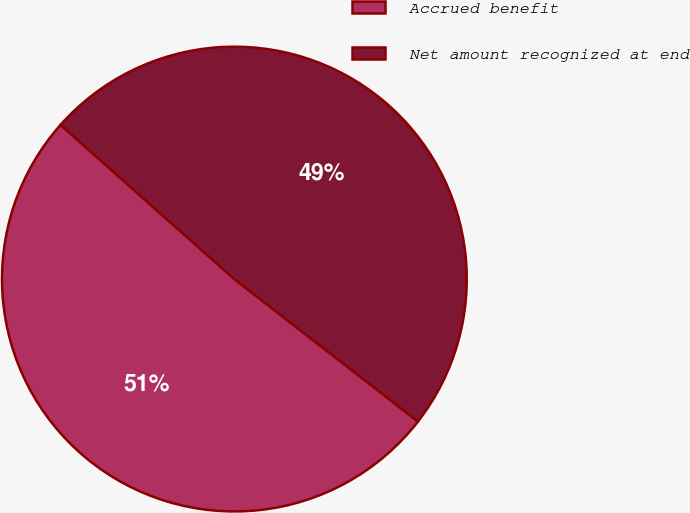Convert chart to OTSL. <chart><loc_0><loc_0><loc_500><loc_500><pie_chart><fcel>Accrued benefit<fcel>Net amount recognized at end<nl><fcel>51.05%<fcel>48.95%<nl></chart> 